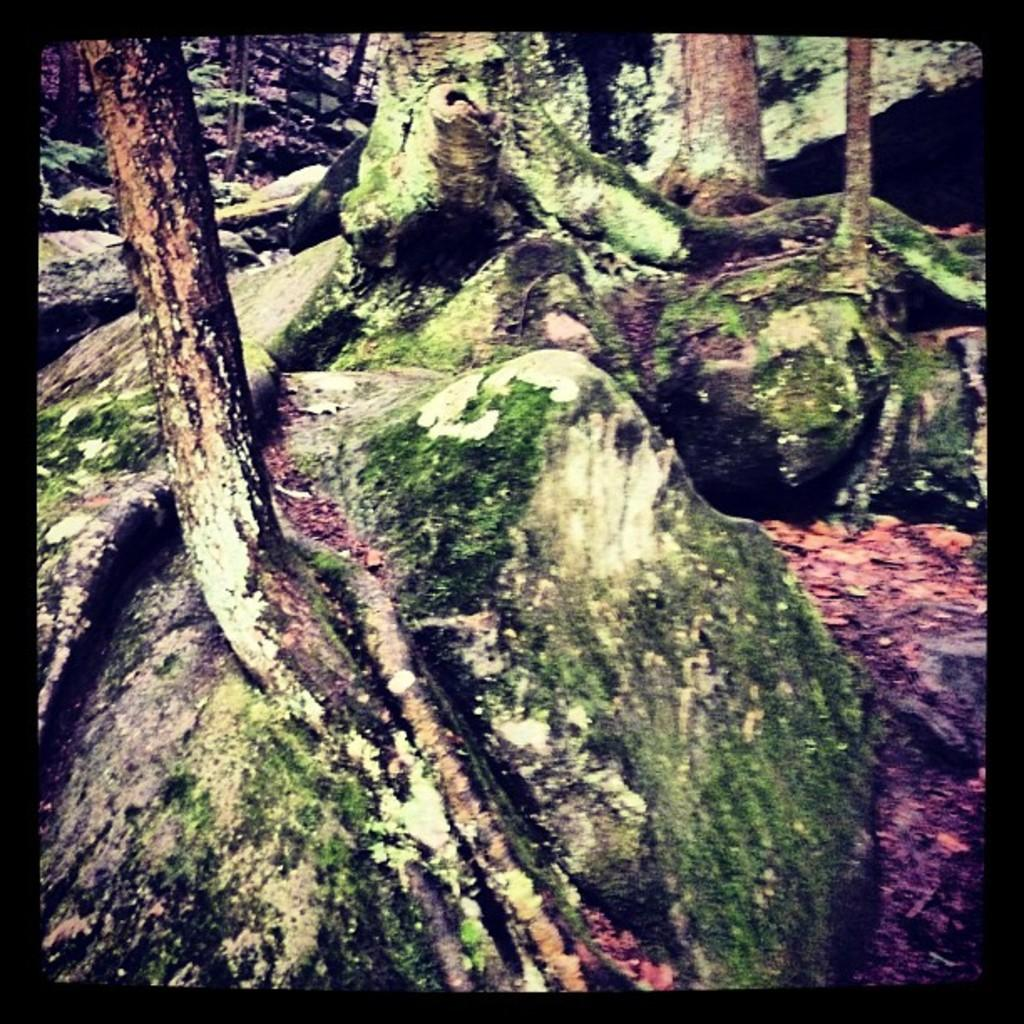What type of natural objects can be seen in the image? There are tree trunks and rocks in the image. Can you describe the tree trunks in the image? The tree trunks appear to be large and sturdy. What other objects can be seen in the image besides the tree trunks? There are rocks in the image. What type of scissors can be seen cutting the tree trunks in the image? There are no scissors present in the image, and the tree trunks are not being cut. What religious symbols can be seen in the image? There are no religious symbols present in the image. 